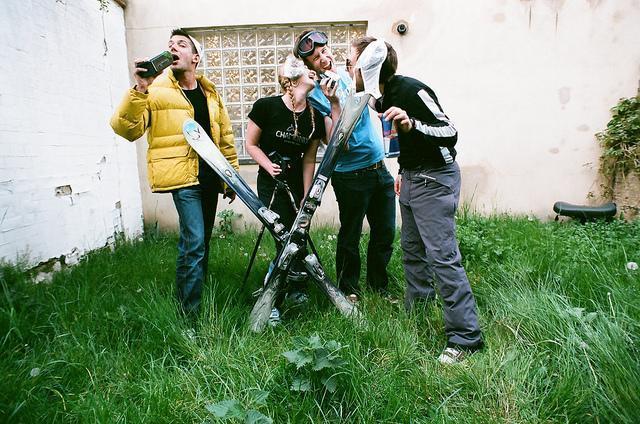How many people are wearing black?
Give a very brief answer. 3. How many people are there?
Give a very brief answer. 4. How many ski can be seen?
Give a very brief answer. 1. 